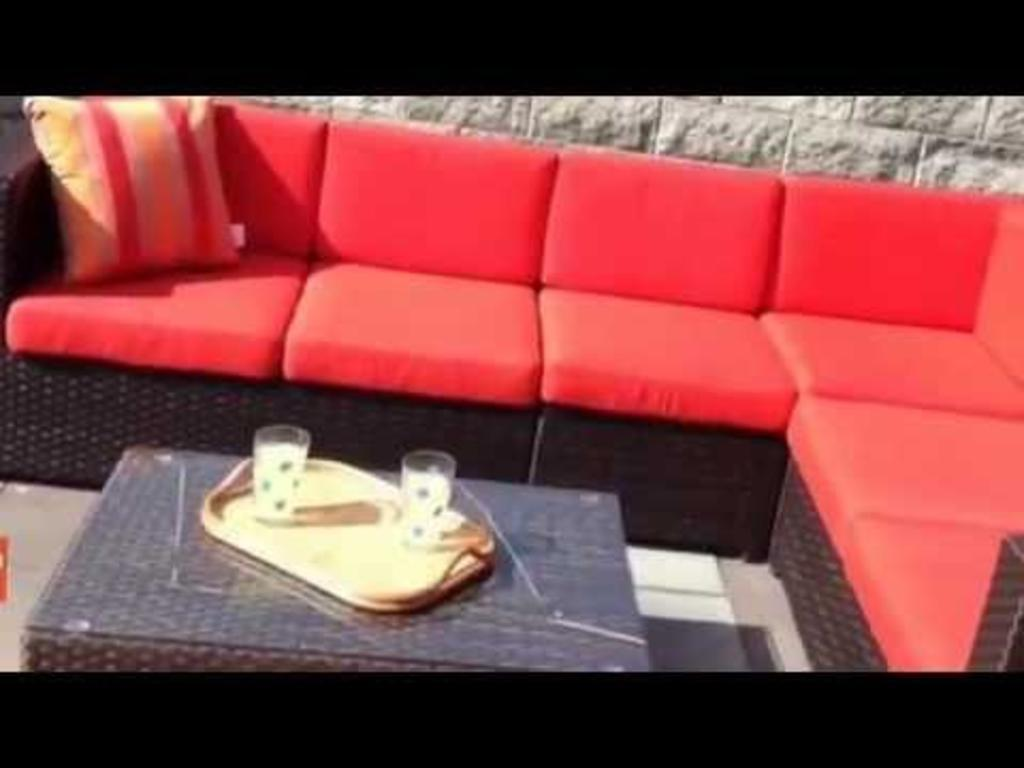What type of furniture is in the image? There is a sofa in the image. What is placed on the sofa? There is a pillow on the sofa. What is in front of the sofa? There is a table in front of the sofa. What is on the table? There is a tray on the table. What is on the tray? There are two glasses on the tray. What can be seen in the background of the image? There is a wall visible in the background of the image. Can you see a giraffe drinking soup from one of the glasses in the image? No, there is no giraffe or soup present in the image. 